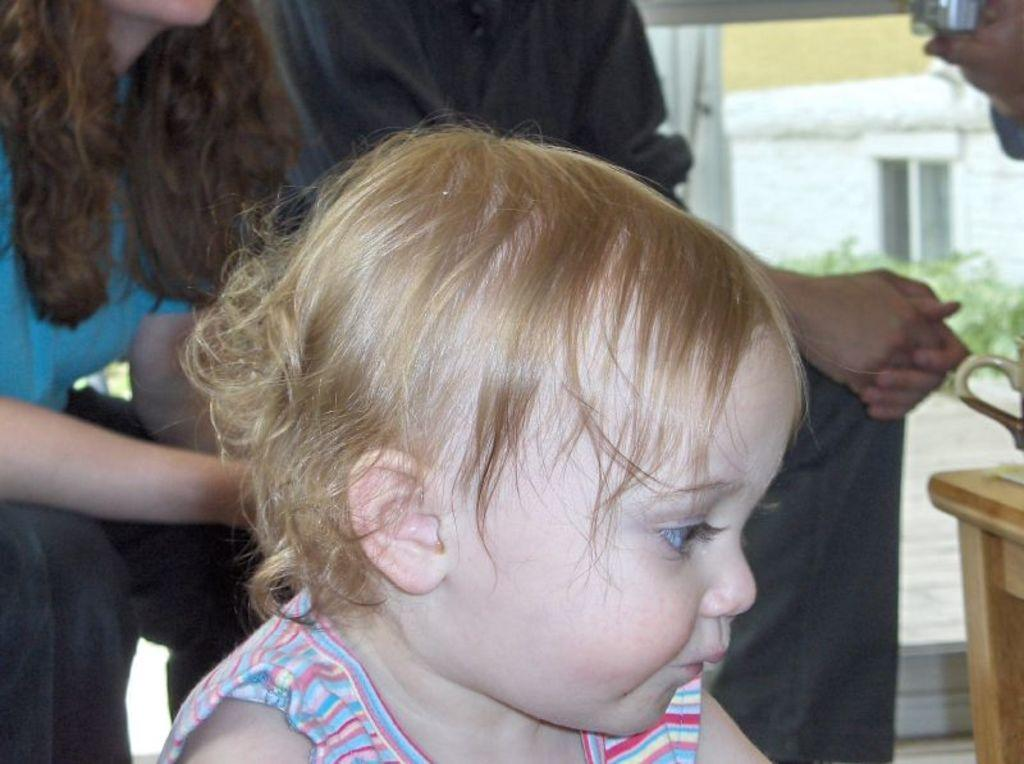Who is the main subject in the image? There is a boy in the image. What else can be seen in the background of the image? There are people in the background of the image. What object is present in the image? There is a table in the image. What type of berry is being harvested at the plantation in the image? There is no plantation or berry present in the image. How many soldiers are visible in the army in the image? There is no army or soldiers present in the image. 